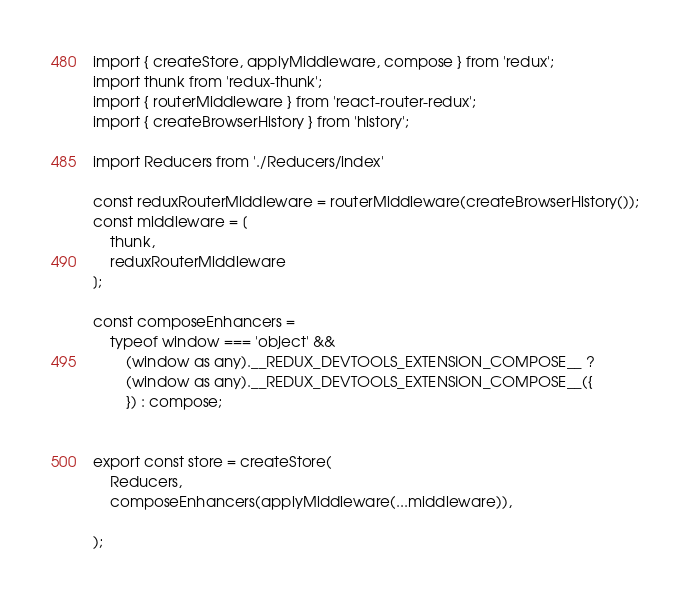<code> <loc_0><loc_0><loc_500><loc_500><_TypeScript_>import { createStore, applyMiddleware, compose } from 'redux';
import thunk from 'redux-thunk';
import { routerMiddleware } from 'react-router-redux';
import { createBrowserHistory } from 'history';

import Reducers from './Reducers/index'

const reduxRouterMiddleware = routerMiddleware(createBrowserHistory());
const middleware = [
    thunk,
    reduxRouterMiddleware
];

const composeEnhancers =
    typeof window === 'object' &&
        (window as any).__REDUX_DEVTOOLS_EXTENSION_COMPOSE__ ?
        (window as any).__REDUX_DEVTOOLS_EXTENSION_COMPOSE__({
        }) : compose;


export const store = createStore(
    Reducers,
    composeEnhancers(applyMiddleware(...middleware)),

);</code> 